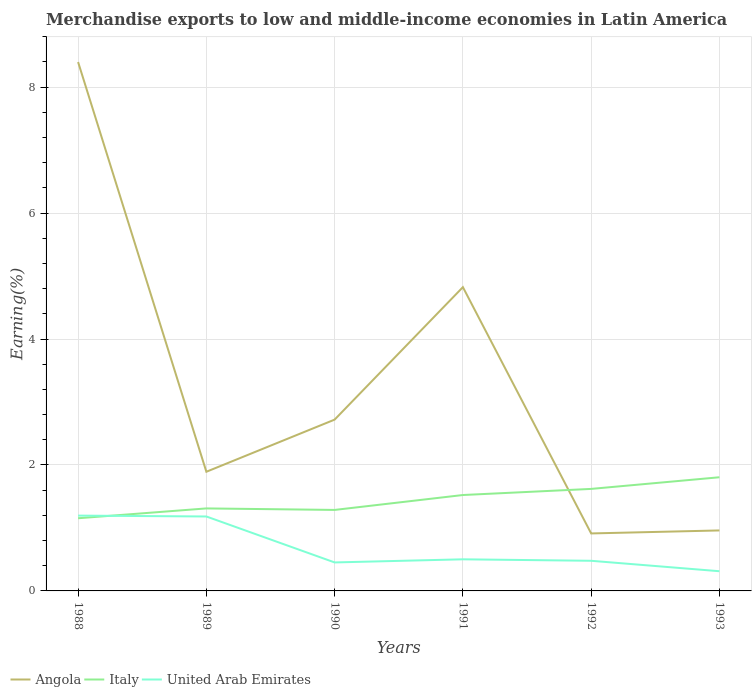Does the line corresponding to Italy intersect with the line corresponding to United Arab Emirates?
Offer a very short reply. Yes. Across all years, what is the maximum percentage of amount earned from merchandise exports in Angola?
Keep it short and to the point. 0.91. What is the total percentage of amount earned from merchandise exports in United Arab Emirates in the graph?
Provide a short and direct response. 0.19. What is the difference between the highest and the second highest percentage of amount earned from merchandise exports in Angola?
Offer a very short reply. 7.49. What is the difference between the highest and the lowest percentage of amount earned from merchandise exports in Italy?
Give a very brief answer. 3. Is the percentage of amount earned from merchandise exports in United Arab Emirates strictly greater than the percentage of amount earned from merchandise exports in Angola over the years?
Your answer should be compact. Yes. How many lines are there?
Provide a short and direct response. 3. Does the graph contain grids?
Provide a short and direct response. Yes. What is the title of the graph?
Your response must be concise. Merchandise exports to low and middle-income economies in Latin America. Does "North America" appear as one of the legend labels in the graph?
Provide a succinct answer. No. What is the label or title of the X-axis?
Offer a very short reply. Years. What is the label or title of the Y-axis?
Ensure brevity in your answer.  Earning(%). What is the Earning(%) of Angola in 1988?
Provide a short and direct response. 8.4. What is the Earning(%) of Italy in 1988?
Ensure brevity in your answer.  1.15. What is the Earning(%) in United Arab Emirates in 1988?
Offer a terse response. 1.2. What is the Earning(%) of Angola in 1989?
Give a very brief answer. 1.89. What is the Earning(%) of Italy in 1989?
Offer a terse response. 1.31. What is the Earning(%) of United Arab Emirates in 1989?
Offer a terse response. 1.18. What is the Earning(%) of Angola in 1990?
Your answer should be very brief. 2.72. What is the Earning(%) of Italy in 1990?
Your response must be concise. 1.29. What is the Earning(%) of United Arab Emirates in 1990?
Give a very brief answer. 0.45. What is the Earning(%) in Angola in 1991?
Your answer should be compact. 4.82. What is the Earning(%) in Italy in 1991?
Ensure brevity in your answer.  1.52. What is the Earning(%) of United Arab Emirates in 1991?
Make the answer very short. 0.5. What is the Earning(%) of Angola in 1992?
Ensure brevity in your answer.  0.91. What is the Earning(%) in Italy in 1992?
Make the answer very short. 1.62. What is the Earning(%) of United Arab Emirates in 1992?
Make the answer very short. 0.48. What is the Earning(%) in Angola in 1993?
Provide a succinct answer. 0.96. What is the Earning(%) of Italy in 1993?
Make the answer very short. 1.8. What is the Earning(%) of United Arab Emirates in 1993?
Offer a very short reply. 0.31. Across all years, what is the maximum Earning(%) in Angola?
Give a very brief answer. 8.4. Across all years, what is the maximum Earning(%) in Italy?
Provide a succinct answer. 1.8. Across all years, what is the maximum Earning(%) in United Arab Emirates?
Ensure brevity in your answer.  1.2. Across all years, what is the minimum Earning(%) of Angola?
Ensure brevity in your answer.  0.91. Across all years, what is the minimum Earning(%) of Italy?
Keep it short and to the point. 1.15. Across all years, what is the minimum Earning(%) in United Arab Emirates?
Provide a short and direct response. 0.31. What is the total Earning(%) in Angola in the graph?
Your answer should be compact. 19.71. What is the total Earning(%) in Italy in the graph?
Provide a short and direct response. 8.7. What is the total Earning(%) of United Arab Emirates in the graph?
Provide a short and direct response. 4.12. What is the difference between the Earning(%) of Angola in 1988 and that in 1989?
Offer a terse response. 6.51. What is the difference between the Earning(%) of Italy in 1988 and that in 1989?
Your answer should be compact. -0.16. What is the difference between the Earning(%) of United Arab Emirates in 1988 and that in 1989?
Make the answer very short. 0.01. What is the difference between the Earning(%) of Angola in 1988 and that in 1990?
Make the answer very short. 5.68. What is the difference between the Earning(%) in Italy in 1988 and that in 1990?
Provide a short and direct response. -0.13. What is the difference between the Earning(%) of United Arab Emirates in 1988 and that in 1990?
Make the answer very short. 0.74. What is the difference between the Earning(%) in Angola in 1988 and that in 1991?
Ensure brevity in your answer.  3.57. What is the difference between the Earning(%) of Italy in 1988 and that in 1991?
Your answer should be compact. -0.37. What is the difference between the Earning(%) of United Arab Emirates in 1988 and that in 1991?
Your answer should be very brief. 0.69. What is the difference between the Earning(%) of Angola in 1988 and that in 1992?
Your answer should be very brief. 7.49. What is the difference between the Earning(%) of Italy in 1988 and that in 1992?
Give a very brief answer. -0.47. What is the difference between the Earning(%) of United Arab Emirates in 1988 and that in 1992?
Provide a succinct answer. 0.72. What is the difference between the Earning(%) in Angola in 1988 and that in 1993?
Ensure brevity in your answer.  7.44. What is the difference between the Earning(%) in Italy in 1988 and that in 1993?
Offer a terse response. -0.65. What is the difference between the Earning(%) of United Arab Emirates in 1988 and that in 1993?
Ensure brevity in your answer.  0.88. What is the difference between the Earning(%) in Angola in 1989 and that in 1990?
Your answer should be very brief. -0.83. What is the difference between the Earning(%) of Italy in 1989 and that in 1990?
Provide a short and direct response. 0.02. What is the difference between the Earning(%) in United Arab Emirates in 1989 and that in 1990?
Make the answer very short. 0.73. What is the difference between the Earning(%) of Angola in 1989 and that in 1991?
Offer a terse response. -2.93. What is the difference between the Earning(%) in Italy in 1989 and that in 1991?
Provide a short and direct response. -0.21. What is the difference between the Earning(%) of United Arab Emirates in 1989 and that in 1991?
Provide a succinct answer. 0.68. What is the difference between the Earning(%) of Angola in 1989 and that in 1992?
Your answer should be very brief. 0.98. What is the difference between the Earning(%) in Italy in 1989 and that in 1992?
Your answer should be very brief. -0.31. What is the difference between the Earning(%) in United Arab Emirates in 1989 and that in 1992?
Provide a short and direct response. 0.7. What is the difference between the Earning(%) in Angola in 1989 and that in 1993?
Keep it short and to the point. 0.93. What is the difference between the Earning(%) in Italy in 1989 and that in 1993?
Keep it short and to the point. -0.49. What is the difference between the Earning(%) in United Arab Emirates in 1989 and that in 1993?
Give a very brief answer. 0.87. What is the difference between the Earning(%) in Angola in 1990 and that in 1991?
Your answer should be compact. -2.1. What is the difference between the Earning(%) in Italy in 1990 and that in 1991?
Your answer should be compact. -0.24. What is the difference between the Earning(%) in United Arab Emirates in 1990 and that in 1991?
Keep it short and to the point. -0.05. What is the difference between the Earning(%) of Angola in 1990 and that in 1992?
Provide a succinct answer. 1.81. What is the difference between the Earning(%) in Italy in 1990 and that in 1992?
Provide a succinct answer. -0.33. What is the difference between the Earning(%) of United Arab Emirates in 1990 and that in 1992?
Keep it short and to the point. -0.03. What is the difference between the Earning(%) of Angola in 1990 and that in 1993?
Keep it short and to the point. 1.76. What is the difference between the Earning(%) of Italy in 1990 and that in 1993?
Give a very brief answer. -0.52. What is the difference between the Earning(%) in United Arab Emirates in 1990 and that in 1993?
Your response must be concise. 0.14. What is the difference between the Earning(%) in Angola in 1991 and that in 1992?
Your response must be concise. 3.91. What is the difference between the Earning(%) of Italy in 1991 and that in 1992?
Give a very brief answer. -0.1. What is the difference between the Earning(%) of United Arab Emirates in 1991 and that in 1992?
Provide a short and direct response. 0.02. What is the difference between the Earning(%) in Angola in 1991 and that in 1993?
Offer a terse response. 3.86. What is the difference between the Earning(%) in Italy in 1991 and that in 1993?
Offer a terse response. -0.28. What is the difference between the Earning(%) of United Arab Emirates in 1991 and that in 1993?
Your answer should be very brief. 0.19. What is the difference between the Earning(%) of Angola in 1992 and that in 1993?
Offer a terse response. -0.05. What is the difference between the Earning(%) in Italy in 1992 and that in 1993?
Your response must be concise. -0.18. What is the difference between the Earning(%) of United Arab Emirates in 1992 and that in 1993?
Provide a succinct answer. 0.17. What is the difference between the Earning(%) of Angola in 1988 and the Earning(%) of Italy in 1989?
Ensure brevity in your answer.  7.09. What is the difference between the Earning(%) of Angola in 1988 and the Earning(%) of United Arab Emirates in 1989?
Make the answer very short. 7.22. What is the difference between the Earning(%) in Italy in 1988 and the Earning(%) in United Arab Emirates in 1989?
Give a very brief answer. -0.03. What is the difference between the Earning(%) in Angola in 1988 and the Earning(%) in Italy in 1990?
Give a very brief answer. 7.11. What is the difference between the Earning(%) of Angola in 1988 and the Earning(%) of United Arab Emirates in 1990?
Give a very brief answer. 7.95. What is the difference between the Earning(%) of Italy in 1988 and the Earning(%) of United Arab Emirates in 1990?
Give a very brief answer. 0.7. What is the difference between the Earning(%) in Angola in 1988 and the Earning(%) in Italy in 1991?
Keep it short and to the point. 6.88. What is the difference between the Earning(%) of Angola in 1988 and the Earning(%) of United Arab Emirates in 1991?
Keep it short and to the point. 7.9. What is the difference between the Earning(%) of Italy in 1988 and the Earning(%) of United Arab Emirates in 1991?
Provide a short and direct response. 0.65. What is the difference between the Earning(%) in Angola in 1988 and the Earning(%) in Italy in 1992?
Give a very brief answer. 6.78. What is the difference between the Earning(%) of Angola in 1988 and the Earning(%) of United Arab Emirates in 1992?
Your answer should be very brief. 7.92. What is the difference between the Earning(%) in Italy in 1988 and the Earning(%) in United Arab Emirates in 1992?
Provide a succinct answer. 0.68. What is the difference between the Earning(%) in Angola in 1988 and the Earning(%) in Italy in 1993?
Keep it short and to the point. 6.59. What is the difference between the Earning(%) in Angola in 1988 and the Earning(%) in United Arab Emirates in 1993?
Your answer should be very brief. 8.09. What is the difference between the Earning(%) of Italy in 1988 and the Earning(%) of United Arab Emirates in 1993?
Ensure brevity in your answer.  0.84. What is the difference between the Earning(%) of Angola in 1989 and the Earning(%) of Italy in 1990?
Your answer should be compact. 0.61. What is the difference between the Earning(%) in Angola in 1989 and the Earning(%) in United Arab Emirates in 1990?
Offer a very short reply. 1.44. What is the difference between the Earning(%) of Italy in 1989 and the Earning(%) of United Arab Emirates in 1990?
Keep it short and to the point. 0.86. What is the difference between the Earning(%) in Angola in 1989 and the Earning(%) in Italy in 1991?
Your answer should be very brief. 0.37. What is the difference between the Earning(%) in Angola in 1989 and the Earning(%) in United Arab Emirates in 1991?
Your response must be concise. 1.39. What is the difference between the Earning(%) of Italy in 1989 and the Earning(%) of United Arab Emirates in 1991?
Provide a succinct answer. 0.81. What is the difference between the Earning(%) of Angola in 1989 and the Earning(%) of Italy in 1992?
Your answer should be compact. 0.27. What is the difference between the Earning(%) in Angola in 1989 and the Earning(%) in United Arab Emirates in 1992?
Keep it short and to the point. 1.41. What is the difference between the Earning(%) of Italy in 1989 and the Earning(%) of United Arab Emirates in 1992?
Offer a terse response. 0.83. What is the difference between the Earning(%) in Angola in 1989 and the Earning(%) in Italy in 1993?
Your response must be concise. 0.09. What is the difference between the Earning(%) of Angola in 1989 and the Earning(%) of United Arab Emirates in 1993?
Your answer should be very brief. 1.58. What is the difference between the Earning(%) in Italy in 1989 and the Earning(%) in United Arab Emirates in 1993?
Ensure brevity in your answer.  1. What is the difference between the Earning(%) in Angola in 1990 and the Earning(%) in Italy in 1991?
Your answer should be compact. 1.2. What is the difference between the Earning(%) of Angola in 1990 and the Earning(%) of United Arab Emirates in 1991?
Ensure brevity in your answer.  2.22. What is the difference between the Earning(%) of Italy in 1990 and the Earning(%) of United Arab Emirates in 1991?
Provide a succinct answer. 0.78. What is the difference between the Earning(%) of Angola in 1990 and the Earning(%) of Italy in 1992?
Ensure brevity in your answer.  1.1. What is the difference between the Earning(%) of Angola in 1990 and the Earning(%) of United Arab Emirates in 1992?
Make the answer very short. 2.24. What is the difference between the Earning(%) of Italy in 1990 and the Earning(%) of United Arab Emirates in 1992?
Ensure brevity in your answer.  0.81. What is the difference between the Earning(%) of Angola in 1990 and the Earning(%) of Italy in 1993?
Offer a very short reply. 0.92. What is the difference between the Earning(%) in Angola in 1990 and the Earning(%) in United Arab Emirates in 1993?
Keep it short and to the point. 2.41. What is the difference between the Earning(%) of Italy in 1990 and the Earning(%) of United Arab Emirates in 1993?
Your response must be concise. 0.97. What is the difference between the Earning(%) of Angola in 1991 and the Earning(%) of Italy in 1992?
Provide a short and direct response. 3.2. What is the difference between the Earning(%) in Angola in 1991 and the Earning(%) in United Arab Emirates in 1992?
Give a very brief answer. 4.34. What is the difference between the Earning(%) in Italy in 1991 and the Earning(%) in United Arab Emirates in 1992?
Provide a short and direct response. 1.04. What is the difference between the Earning(%) in Angola in 1991 and the Earning(%) in Italy in 1993?
Ensure brevity in your answer.  3.02. What is the difference between the Earning(%) in Angola in 1991 and the Earning(%) in United Arab Emirates in 1993?
Your response must be concise. 4.51. What is the difference between the Earning(%) of Italy in 1991 and the Earning(%) of United Arab Emirates in 1993?
Your answer should be compact. 1.21. What is the difference between the Earning(%) in Angola in 1992 and the Earning(%) in Italy in 1993?
Your answer should be very brief. -0.89. What is the difference between the Earning(%) in Angola in 1992 and the Earning(%) in United Arab Emirates in 1993?
Ensure brevity in your answer.  0.6. What is the difference between the Earning(%) in Italy in 1992 and the Earning(%) in United Arab Emirates in 1993?
Your answer should be very brief. 1.31. What is the average Earning(%) of Angola per year?
Give a very brief answer. 3.28. What is the average Earning(%) in Italy per year?
Keep it short and to the point. 1.45. What is the average Earning(%) of United Arab Emirates per year?
Keep it short and to the point. 0.69. In the year 1988, what is the difference between the Earning(%) of Angola and Earning(%) of Italy?
Ensure brevity in your answer.  7.24. In the year 1988, what is the difference between the Earning(%) in Angola and Earning(%) in United Arab Emirates?
Offer a very short reply. 7.2. In the year 1988, what is the difference between the Earning(%) in Italy and Earning(%) in United Arab Emirates?
Your response must be concise. -0.04. In the year 1989, what is the difference between the Earning(%) in Angola and Earning(%) in Italy?
Keep it short and to the point. 0.58. In the year 1989, what is the difference between the Earning(%) of Angola and Earning(%) of United Arab Emirates?
Your answer should be very brief. 0.71. In the year 1989, what is the difference between the Earning(%) of Italy and Earning(%) of United Arab Emirates?
Make the answer very short. 0.13. In the year 1990, what is the difference between the Earning(%) of Angola and Earning(%) of Italy?
Ensure brevity in your answer.  1.43. In the year 1990, what is the difference between the Earning(%) of Angola and Earning(%) of United Arab Emirates?
Keep it short and to the point. 2.27. In the year 1990, what is the difference between the Earning(%) of Italy and Earning(%) of United Arab Emirates?
Give a very brief answer. 0.83. In the year 1991, what is the difference between the Earning(%) of Angola and Earning(%) of Italy?
Make the answer very short. 3.3. In the year 1991, what is the difference between the Earning(%) of Angola and Earning(%) of United Arab Emirates?
Your response must be concise. 4.32. In the year 1991, what is the difference between the Earning(%) in Italy and Earning(%) in United Arab Emirates?
Offer a terse response. 1.02. In the year 1992, what is the difference between the Earning(%) in Angola and Earning(%) in Italy?
Your response must be concise. -0.71. In the year 1992, what is the difference between the Earning(%) in Angola and Earning(%) in United Arab Emirates?
Offer a very short reply. 0.43. In the year 1992, what is the difference between the Earning(%) in Italy and Earning(%) in United Arab Emirates?
Keep it short and to the point. 1.14. In the year 1993, what is the difference between the Earning(%) of Angola and Earning(%) of Italy?
Ensure brevity in your answer.  -0.84. In the year 1993, what is the difference between the Earning(%) in Angola and Earning(%) in United Arab Emirates?
Provide a short and direct response. 0.65. In the year 1993, what is the difference between the Earning(%) in Italy and Earning(%) in United Arab Emirates?
Offer a terse response. 1.49. What is the ratio of the Earning(%) of Angola in 1988 to that in 1989?
Keep it short and to the point. 4.44. What is the ratio of the Earning(%) in Italy in 1988 to that in 1989?
Offer a very short reply. 0.88. What is the ratio of the Earning(%) in United Arab Emirates in 1988 to that in 1989?
Your answer should be compact. 1.01. What is the ratio of the Earning(%) in Angola in 1988 to that in 1990?
Make the answer very short. 3.09. What is the ratio of the Earning(%) in Italy in 1988 to that in 1990?
Ensure brevity in your answer.  0.9. What is the ratio of the Earning(%) of United Arab Emirates in 1988 to that in 1990?
Offer a very short reply. 2.64. What is the ratio of the Earning(%) of Angola in 1988 to that in 1991?
Give a very brief answer. 1.74. What is the ratio of the Earning(%) of Italy in 1988 to that in 1991?
Offer a very short reply. 0.76. What is the ratio of the Earning(%) of United Arab Emirates in 1988 to that in 1991?
Your answer should be very brief. 2.38. What is the ratio of the Earning(%) of Angola in 1988 to that in 1992?
Your answer should be compact. 9.2. What is the ratio of the Earning(%) in Italy in 1988 to that in 1992?
Offer a very short reply. 0.71. What is the ratio of the Earning(%) in United Arab Emirates in 1988 to that in 1992?
Your answer should be compact. 2.5. What is the ratio of the Earning(%) of Angola in 1988 to that in 1993?
Give a very brief answer. 8.74. What is the ratio of the Earning(%) in Italy in 1988 to that in 1993?
Make the answer very short. 0.64. What is the ratio of the Earning(%) in United Arab Emirates in 1988 to that in 1993?
Provide a short and direct response. 3.82. What is the ratio of the Earning(%) of Angola in 1989 to that in 1990?
Ensure brevity in your answer.  0.7. What is the ratio of the Earning(%) in Italy in 1989 to that in 1990?
Your response must be concise. 1.02. What is the ratio of the Earning(%) of United Arab Emirates in 1989 to that in 1990?
Your answer should be compact. 2.61. What is the ratio of the Earning(%) in Angola in 1989 to that in 1991?
Offer a very short reply. 0.39. What is the ratio of the Earning(%) in Italy in 1989 to that in 1991?
Give a very brief answer. 0.86. What is the ratio of the Earning(%) of United Arab Emirates in 1989 to that in 1991?
Provide a succinct answer. 2.35. What is the ratio of the Earning(%) in Angola in 1989 to that in 1992?
Your response must be concise. 2.07. What is the ratio of the Earning(%) of Italy in 1989 to that in 1992?
Your response must be concise. 0.81. What is the ratio of the Earning(%) in United Arab Emirates in 1989 to that in 1992?
Give a very brief answer. 2.47. What is the ratio of the Earning(%) of Angola in 1989 to that in 1993?
Make the answer very short. 1.97. What is the ratio of the Earning(%) of Italy in 1989 to that in 1993?
Your response must be concise. 0.73. What is the ratio of the Earning(%) of United Arab Emirates in 1989 to that in 1993?
Give a very brief answer. 3.78. What is the ratio of the Earning(%) in Angola in 1990 to that in 1991?
Make the answer very short. 0.56. What is the ratio of the Earning(%) of Italy in 1990 to that in 1991?
Offer a terse response. 0.84. What is the ratio of the Earning(%) of United Arab Emirates in 1990 to that in 1991?
Make the answer very short. 0.9. What is the ratio of the Earning(%) in Angola in 1990 to that in 1992?
Your answer should be very brief. 2.98. What is the ratio of the Earning(%) of Italy in 1990 to that in 1992?
Your answer should be very brief. 0.79. What is the ratio of the Earning(%) in United Arab Emirates in 1990 to that in 1992?
Give a very brief answer. 0.95. What is the ratio of the Earning(%) of Angola in 1990 to that in 1993?
Offer a terse response. 2.83. What is the ratio of the Earning(%) of Italy in 1990 to that in 1993?
Offer a terse response. 0.71. What is the ratio of the Earning(%) in United Arab Emirates in 1990 to that in 1993?
Make the answer very short. 1.45. What is the ratio of the Earning(%) in Angola in 1991 to that in 1992?
Your response must be concise. 5.28. What is the ratio of the Earning(%) of United Arab Emirates in 1991 to that in 1992?
Your answer should be very brief. 1.05. What is the ratio of the Earning(%) of Angola in 1991 to that in 1993?
Ensure brevity in your answer.  5.02. What is the ratio of the Earning(%) of Italy in 1991 to that in 1993?
Ensure brevity in your answer.  0.84. What is the ratio of the Earning(%) of United Arab Emirates in 1991 to that in 1993?
Provide a short and direct response. 1.6. What is the ratio of the Earning(%) of Angola in 1992 to that in 1993?
Offer a very short reply. 0.95. What is the ratio of the Earning(%) of Italy in 1992 to that in 1993?
Offer a terse response. 0.9. What is the ratio of the Earning(%) of United Arab Emirates in 1992 to that in 1993?
Your answer should be very brief. 1.53. What is the difference between the highest and the second highest Earning(%) in Angola?
Give a very brief answer. 3.57. What is the difference between the highest and the second highest Earning(%) of Italy?
Offer a terse response. 0.18. What is the difference between the highest and the second highest Earning(%) of United Arab Emirates?
Your answer should be very brief. 0.01. What is the difference between the highest and the lowest Earning(%) of Angola?
Give a very brief answer. 7.49. What is the difference between the highest and the lowest Earning(%) in Italy?
Your answer should be compact. 0.65. What is the difference between the highest and the lowest Earning(%) of United Arab Emirates?
Make the answer very short. 0.88. 